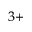<formula> <loc_0><loc_0><loc_500><loc_500>^ { 3 + }</formula> 